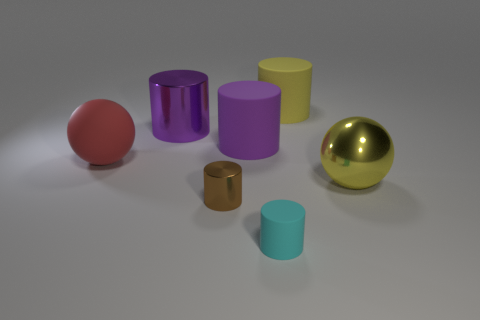Is the lighting in the image natural or artificial, and how can you tell? The lighting in the image appears to be artificial. The evidence of this includes the soft, uniform shadows indicating diffused lighting often used in studio settings, and the lack of any natural elements like windows or sun glare that would suggest natural lighting. 